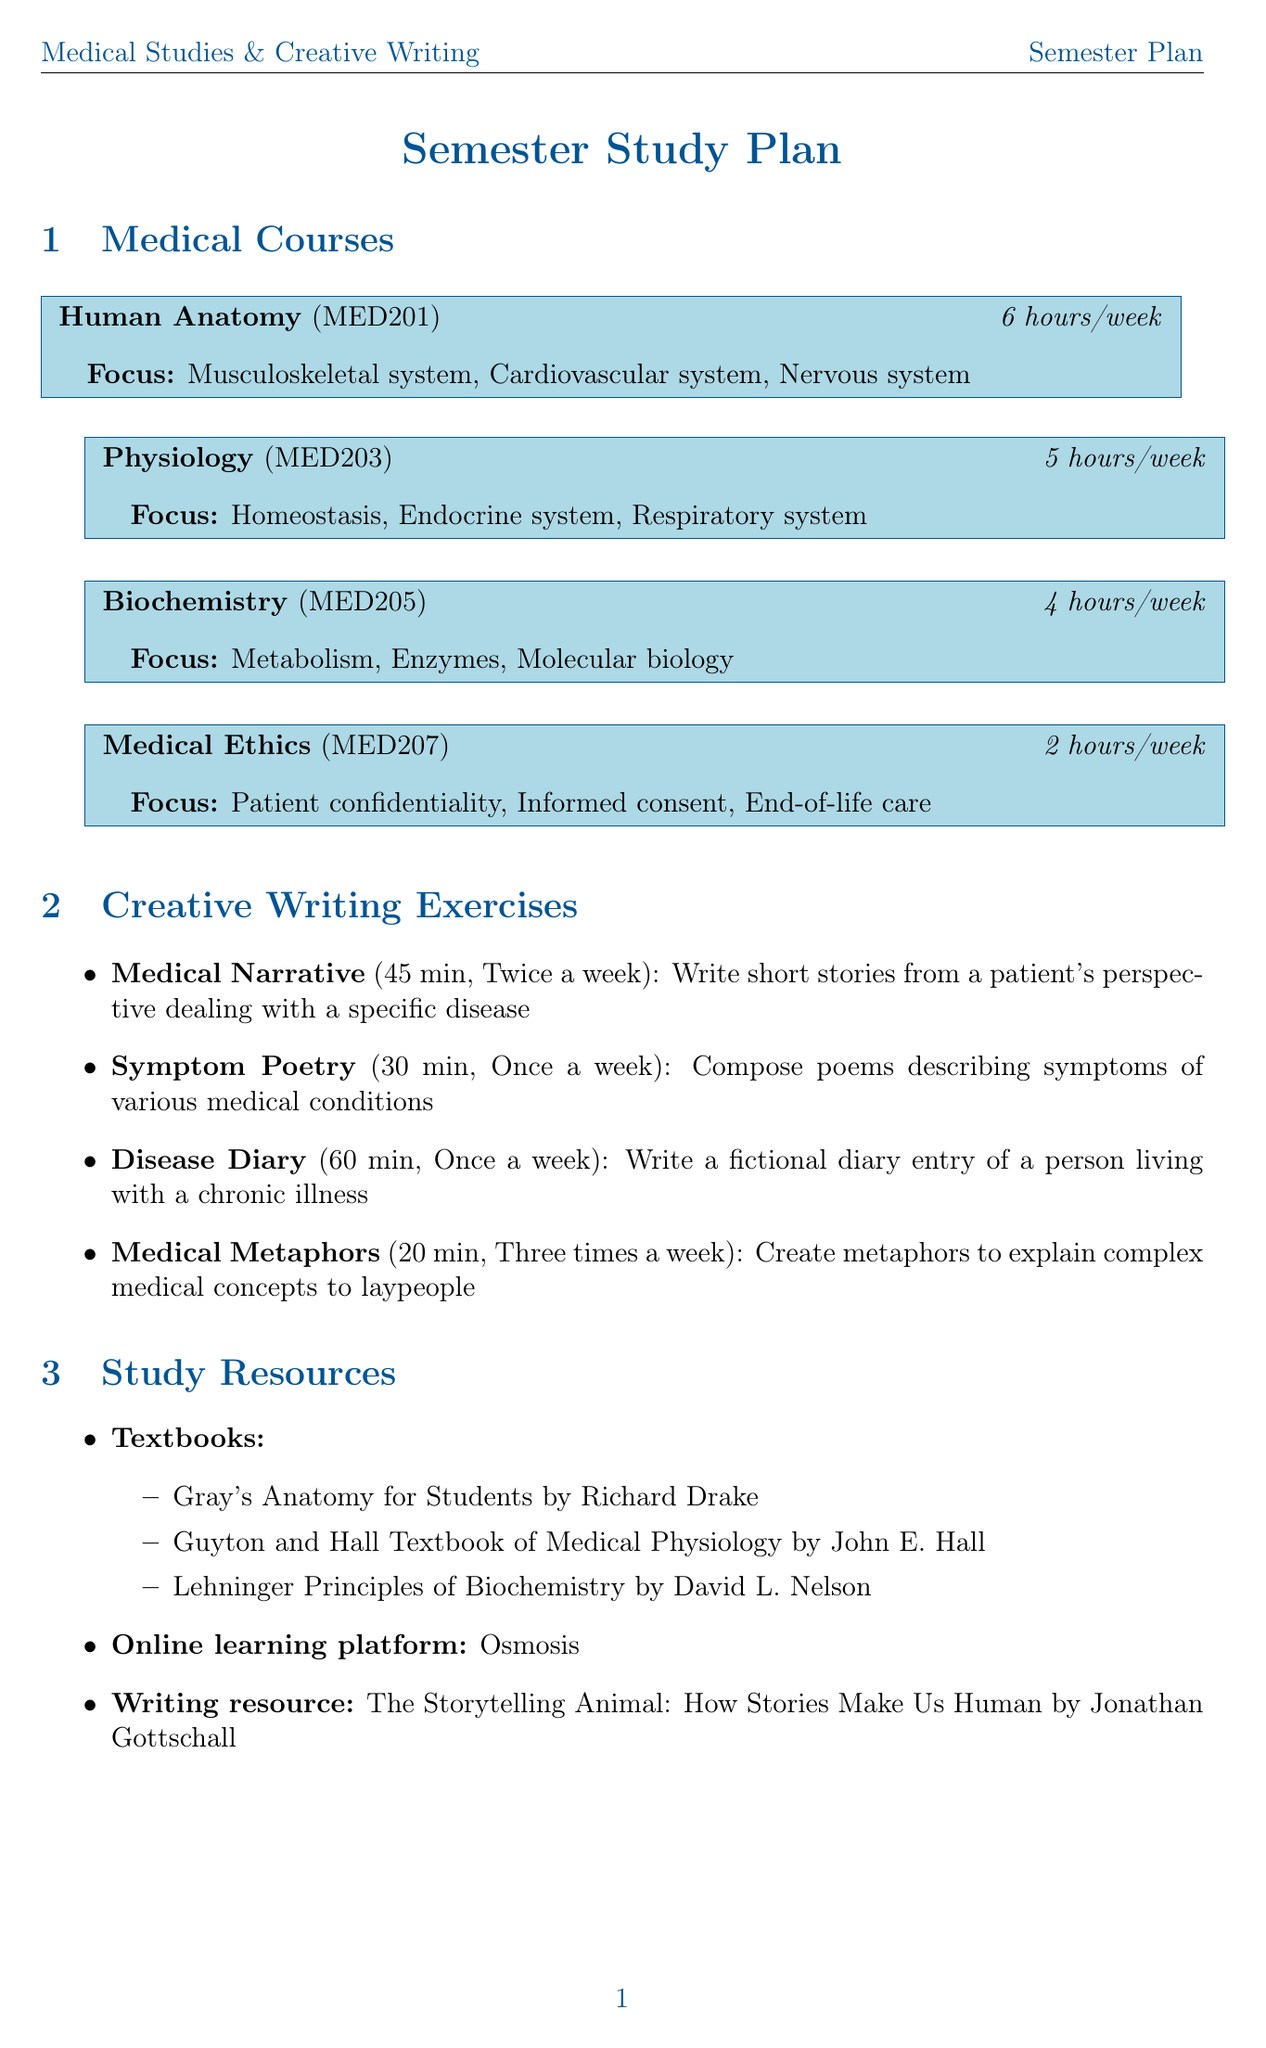What is the total length of the semester? The semester length is explicitly stated as 16 weeks.
Answer: 16 weeks How many hours per week is dedicated to Human Anatomy? The weekly hours for Human Anatomy are specifically listed as 6 hours.
Answer: 6 What writing exercise involves creating metaphors? The document lists "Medical Metaphors" as the writing exercise related to metaphors.
Answer: Medical Metaphors How many health education pamphlets are to be created? The document specifies a target of 5 health education pamphlets to be created.
Answer: 5 What frequency are the Medical Writers Association meetings held? The frequency of the Medical Writers Association meetings is mentioned as monthly.
Answer: Monthly What is the total weekly hours spent on Medical Ethics? The document indicates that Medical Ethics has a weekly commitment of 2 hours.
Answer: 2 In which week do the Midterm Examinations occur? The document states that Midterm Examinations take place in week 8.
Answer: Week 8 How frequently is the "Disease Diary" writing exercise performed? "Disease Diary" is listed in the document as an exercise done once a week.
Answer: Once a week What are the two main focuses of Biochemistry? The document outlines "Metabolism" and "Enzymes" as two key focuses of the Biochemistry course.
Answer: Metabolism, Enzymes 